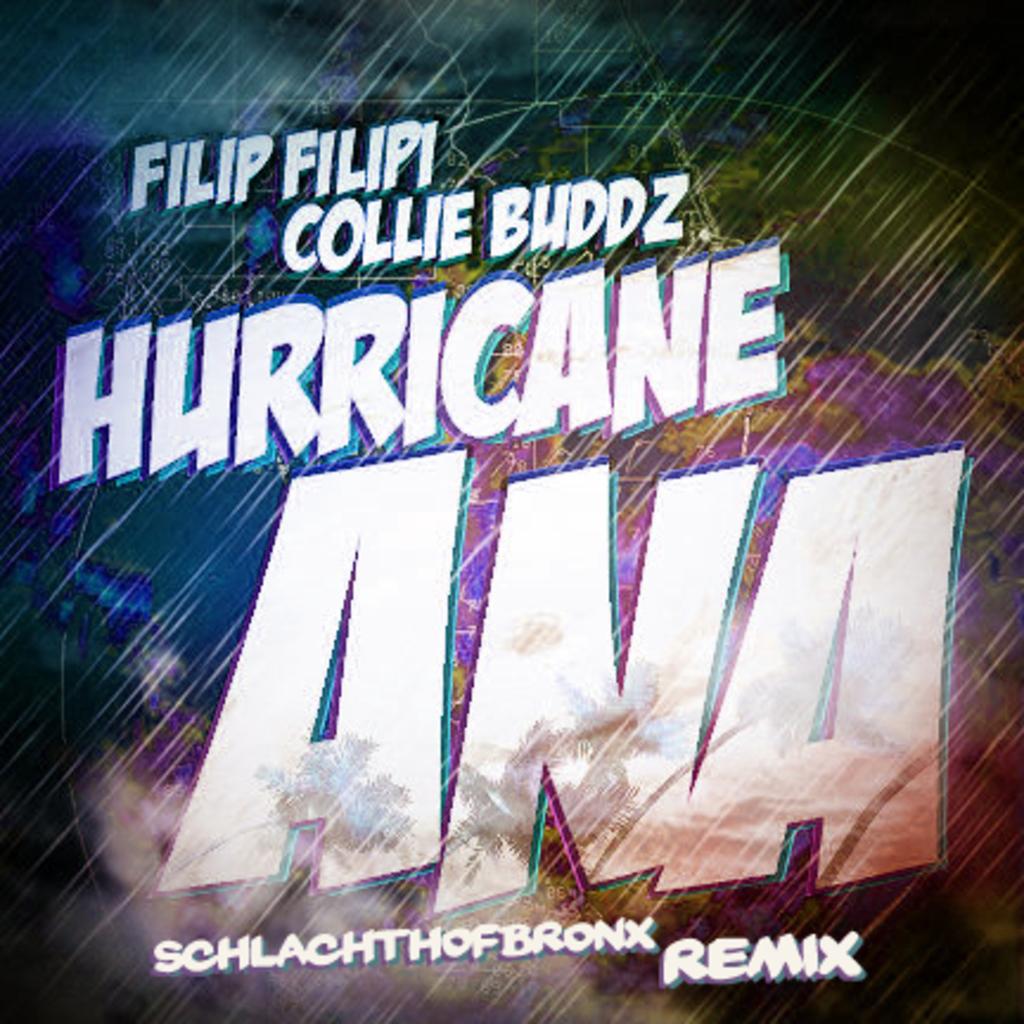What type of storm is ana?
Offer a very short reply. Hurricane. Who are the artists of this?
Your answer should be very brief. Filip filipi. 